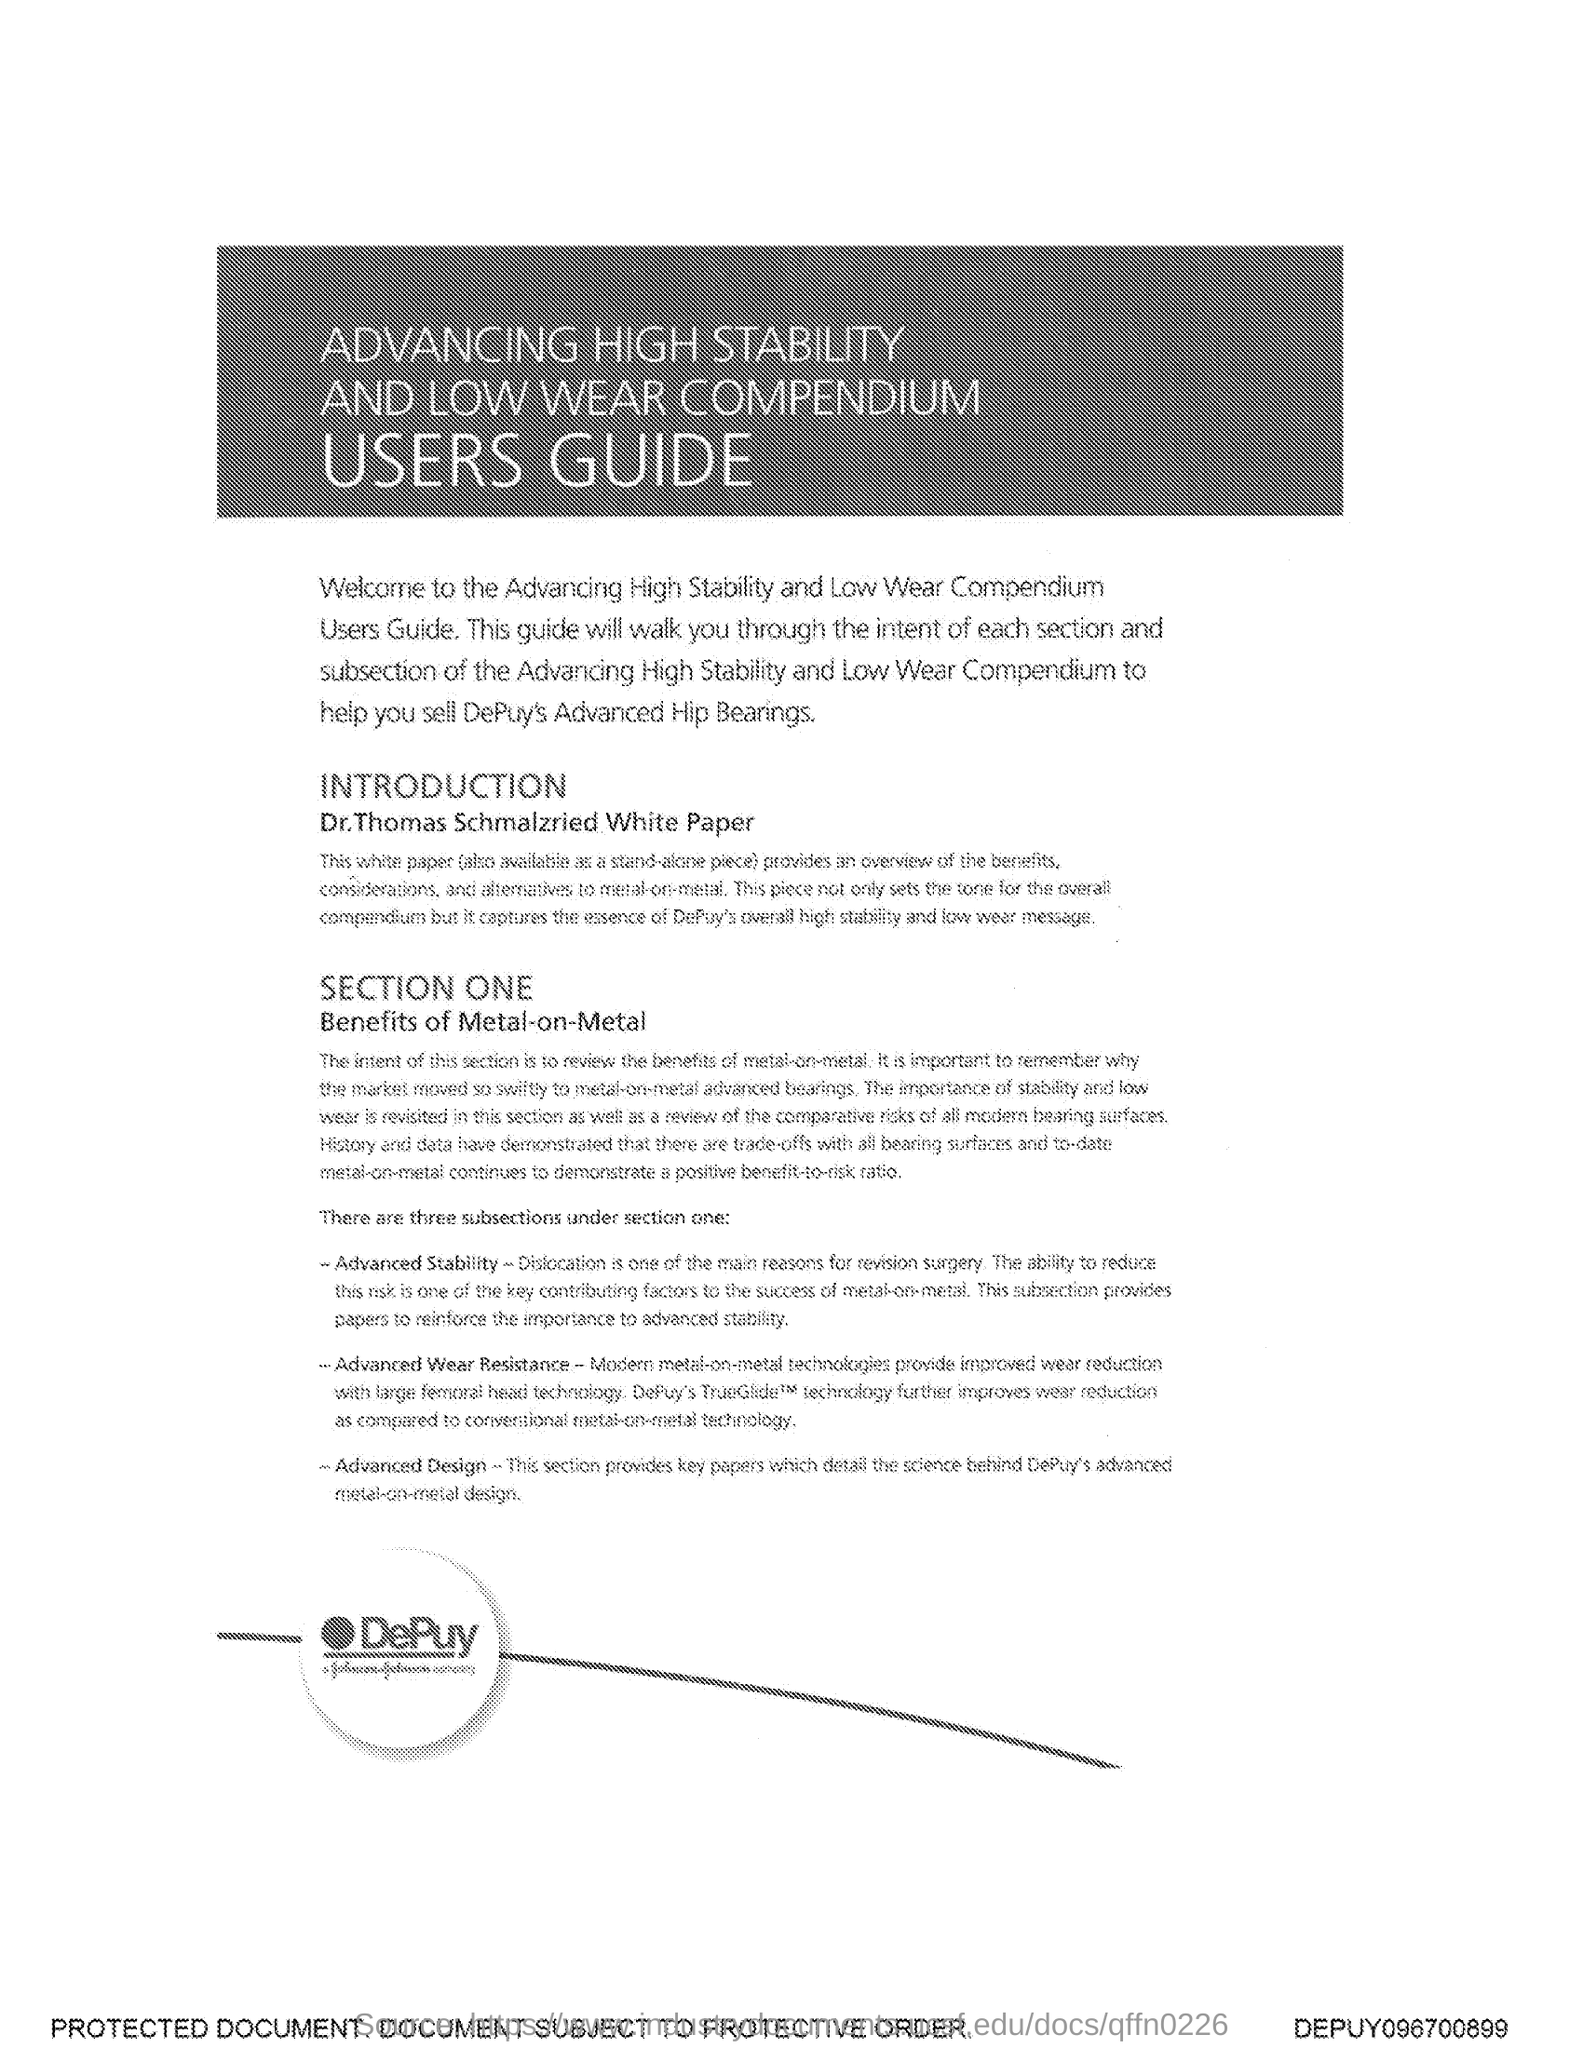What is the title of the document?
Offer a very short reply. Advancing High Stability and Low Wear Compendium Users Guide. 